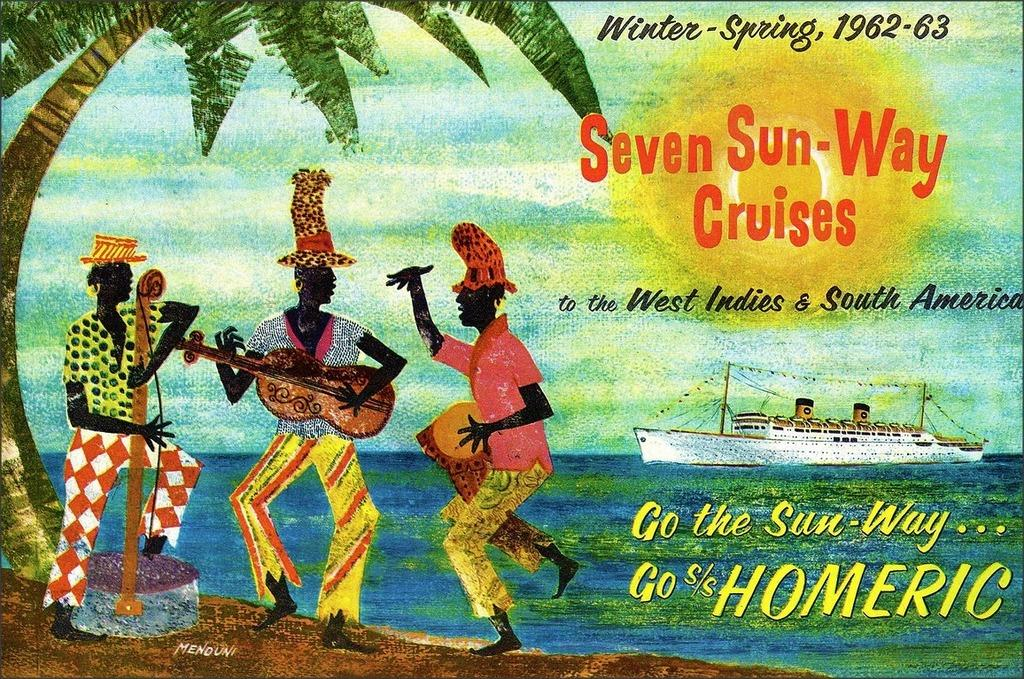<image>
Provide a brief description of the given image. an image that has a quote of seven sun way on it 